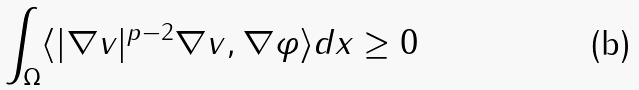<formula> <loc_0><loc_0><loc_500><loc_500>\int _ { \Omega } \langle | \nabla v | ^ { p - 2 } \nabla v , \nabla \varphi \rangle d x \geq 0</formula> 